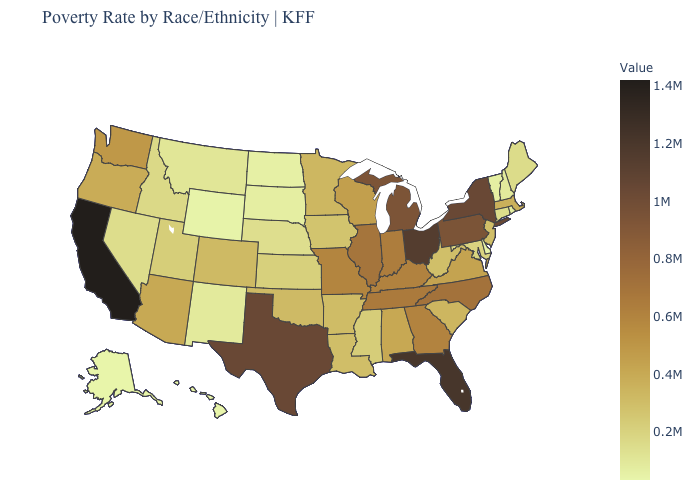Which states have the lowest value in the West?
Give a very brief answer. Hawaii. Does the map have missing data?
Keep it brief. No. Which states hav the highest value in the South?
Quick response, please. Florida. Does Tennessee have a lower value than New Mexico?
Answer briefly. No. 